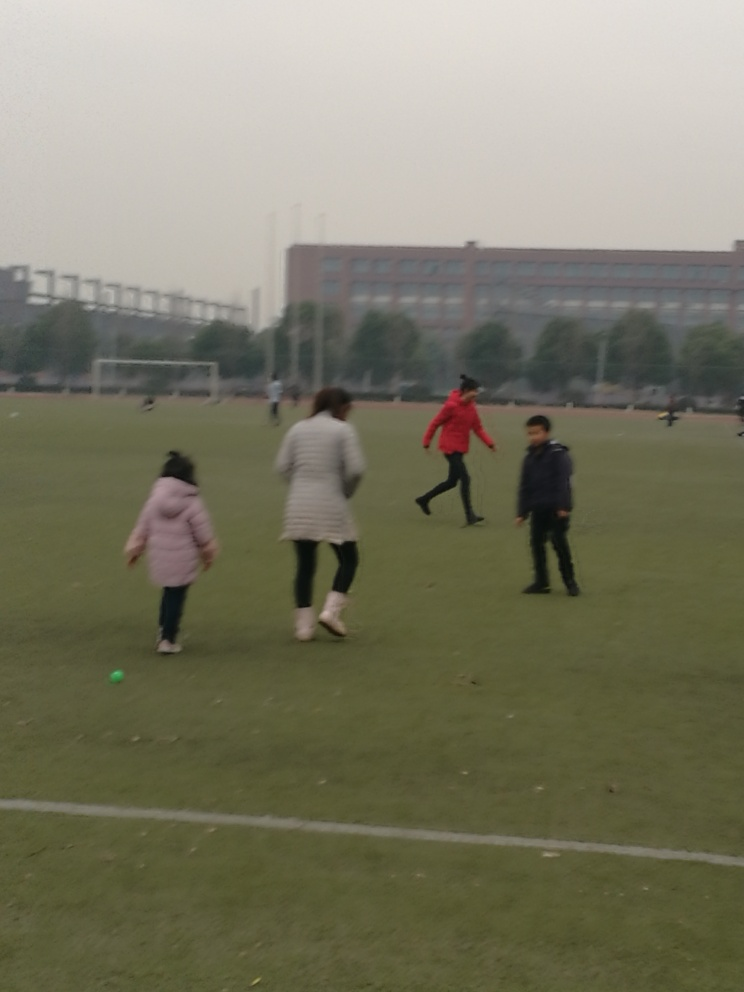Describe the environment around the people. The people are in an expansive, open grassy area, which looks like a recreational field. In the background, there is a large building, possibly an institutional structure, and the lack of foliage indicates it could be during the colder seasons or in an area where trees are sparse. 